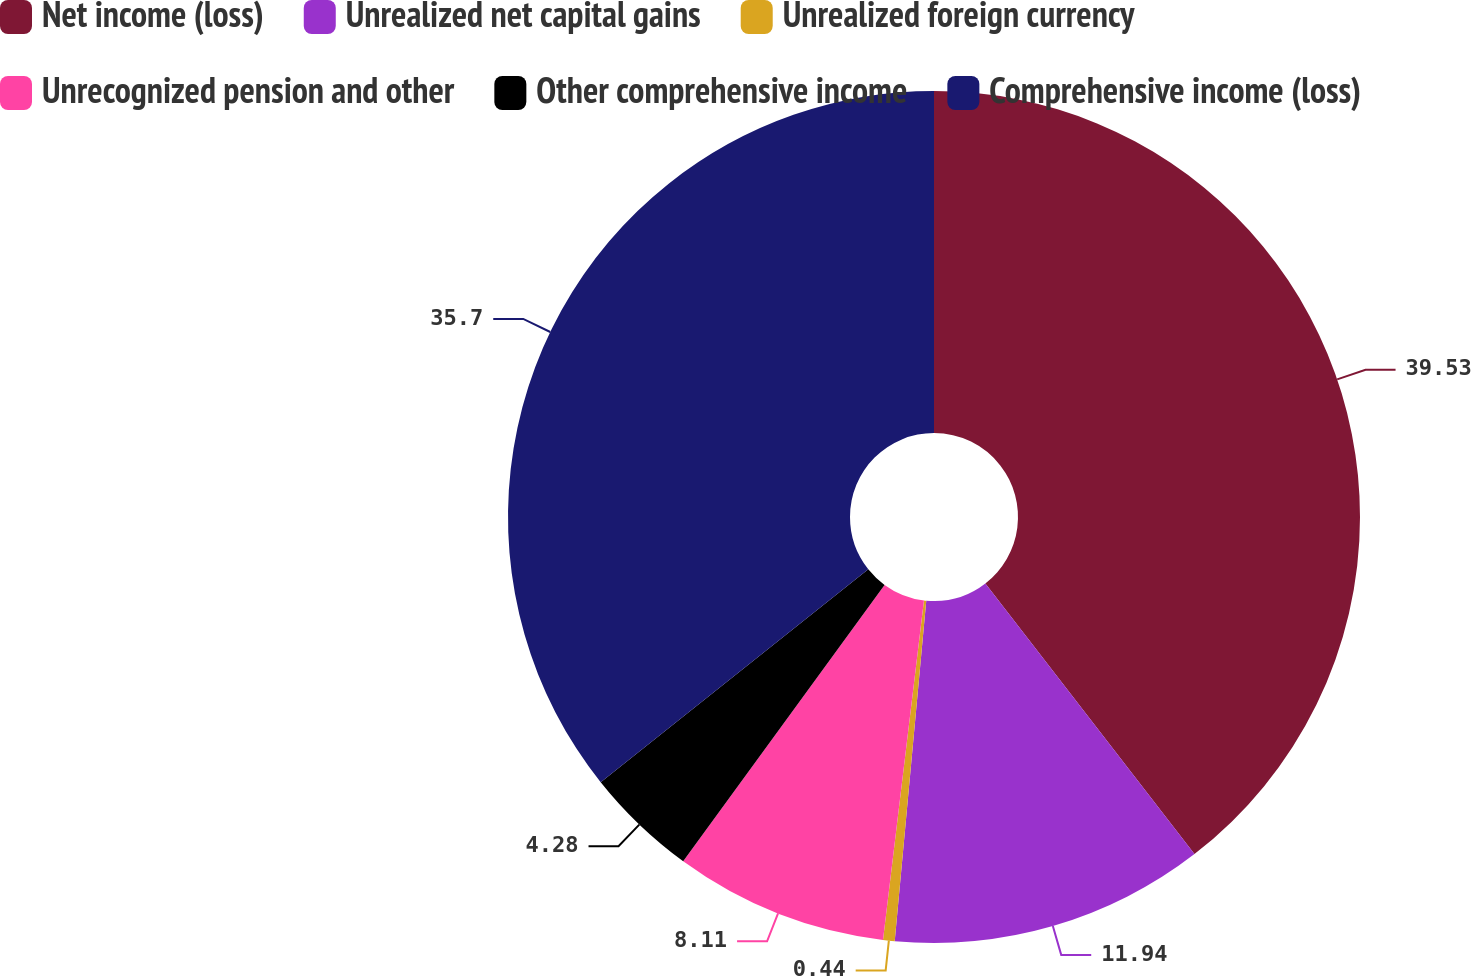Convert chart to OTSL. <chart><loc_0><loc_0><loc_500><loc_500><pie_chart><fcel>Net income (loss)<fcel>Unrealized net capital gains<fcel>Unrealized foreign currency<fcel>Unrecognized pension and other<fcel>Other comprehensive income<fcel>Comprehensive income (loss)<nl><fcel>39.53%<fcel>11.94%<fcel>0.44%<fcel>8.11%<fcel>4.28%<fcel>35.7%<nl></chart> 